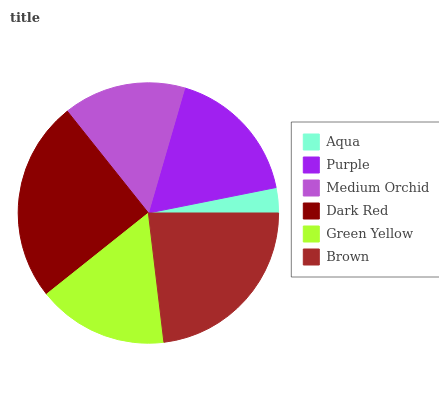Is Aqua the minimum?
Answer yes or no. Yes. Is Dark Red the maximum?
Answer yes or no. Yes. Is Purple the minimum?
Answer yes or no. No. Is Purple the maximum?
Answer yes or no. No. Is Purple greater than Aqua?
Answer yes or no. Yes. Is Aqua less than Purple?
Answer yes or no. Yes. Is Aqua greater than Purple?
Answer yes or no. No. Is Purple less than Aqua?
Answer yes or no. No. Is Purple the high median?
Answer yes or no. Yes. Is Green Yellow the low median?
Answer yes or no. Yes. Is Green Yellow the high median?
Answer yes or no. No. Is Medium Orchid the low median?
Answer yes or no. No. 